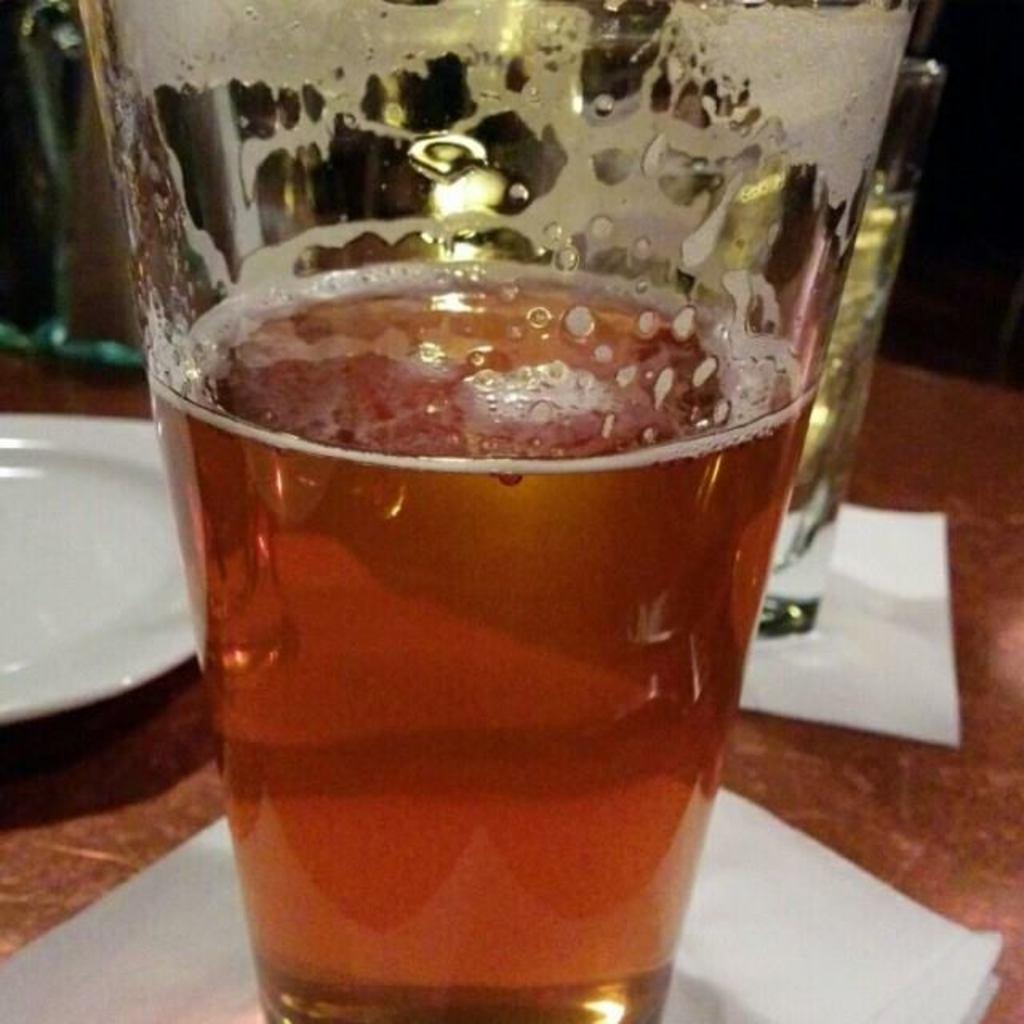Can you describe this image briefly? In this image, we can see some glasses with liquid. We can also see some papers and a plate. 